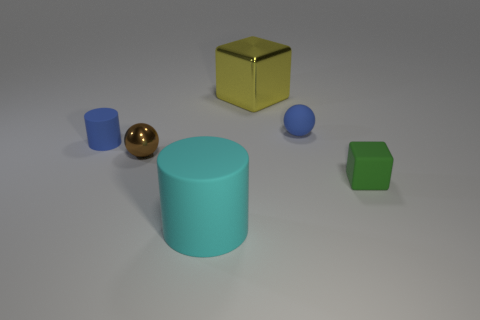Add 4 large cyan cylinders. How many objects exist? 10 Subtract all spheres. How many objects are left? 4 Subtract all gray rubber objects. Subtract all blocks. How many objects are left? 4 Add 4 green objects. How many green objects are left? 5 Add 4 blue rubber spheres. How many blue rubber spheres exist? 5 Subtract 1 brown balls. How many objects are left? 5 